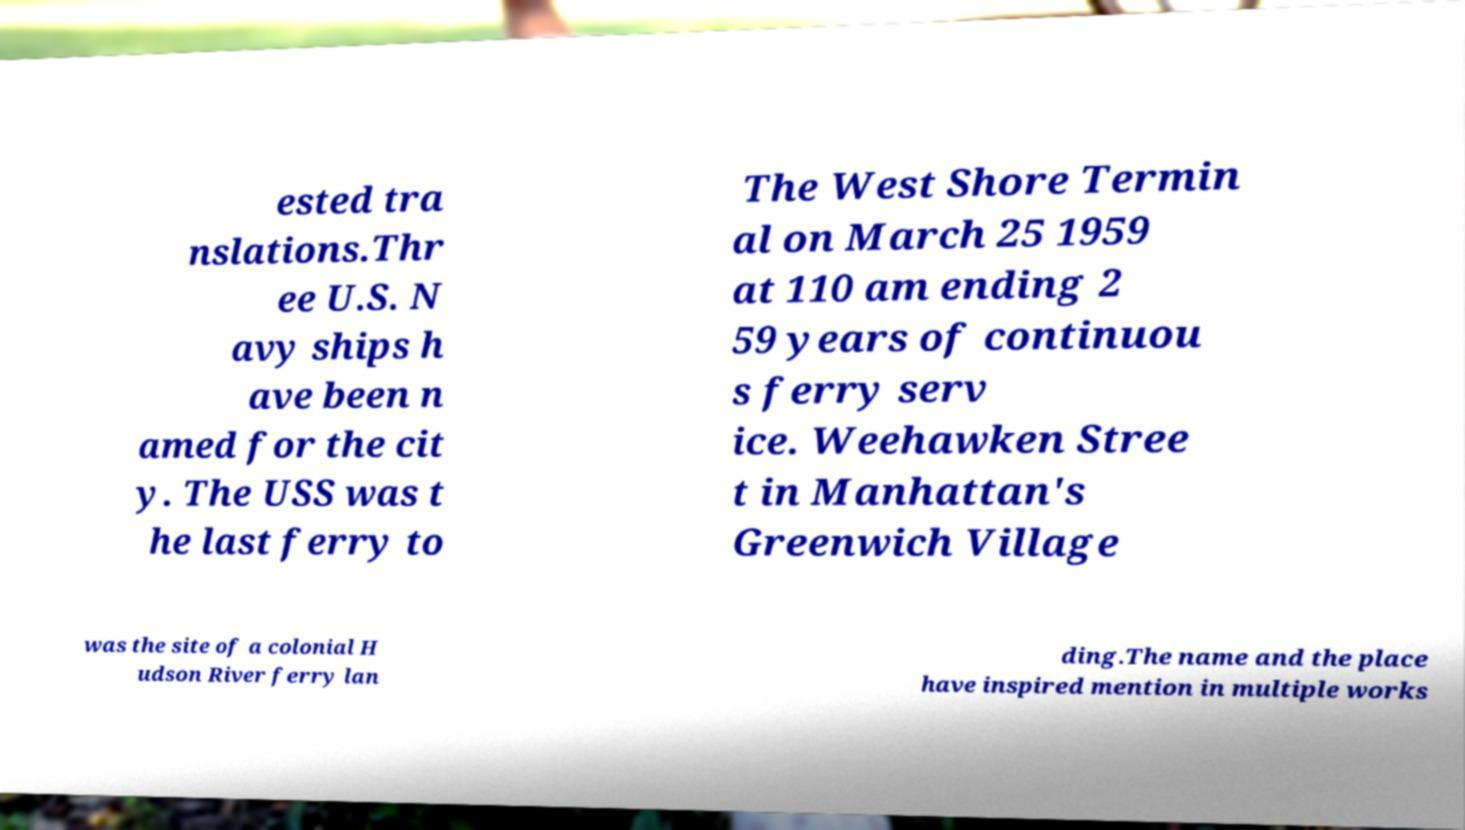For documentation purposes, I need the text within this image transcribed. Could you provide that? ested tra nslations.Thr ee U.S. N avy ships h ave been n amed for the cit y. The USS was t he last ferry to The West Shore Termin al on March 25 1959 at 110 am ending 2 59 years of continuou s ferry serv ice. Weehawken Stree t in Manhattan's Greenwich Village was the site of a colonial H udson River ferry lan ding.The name and the place have inspired mention in multiple works 